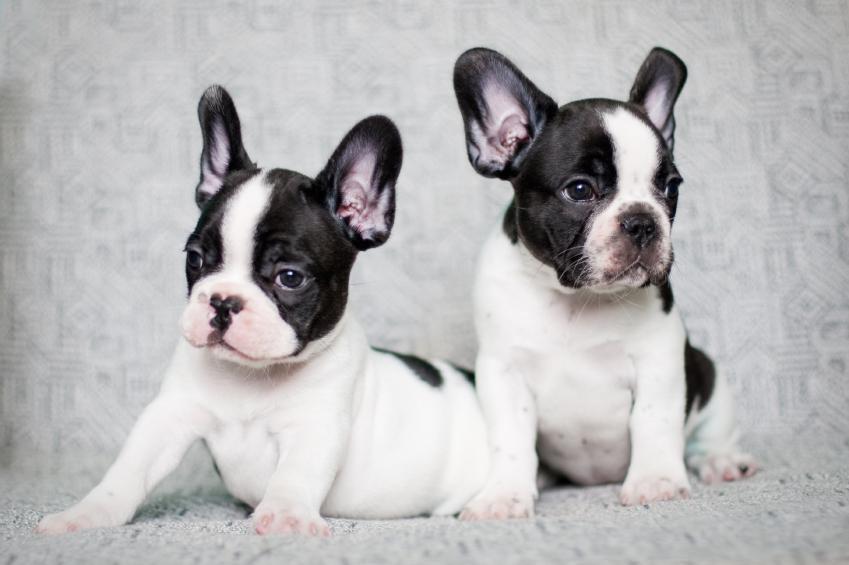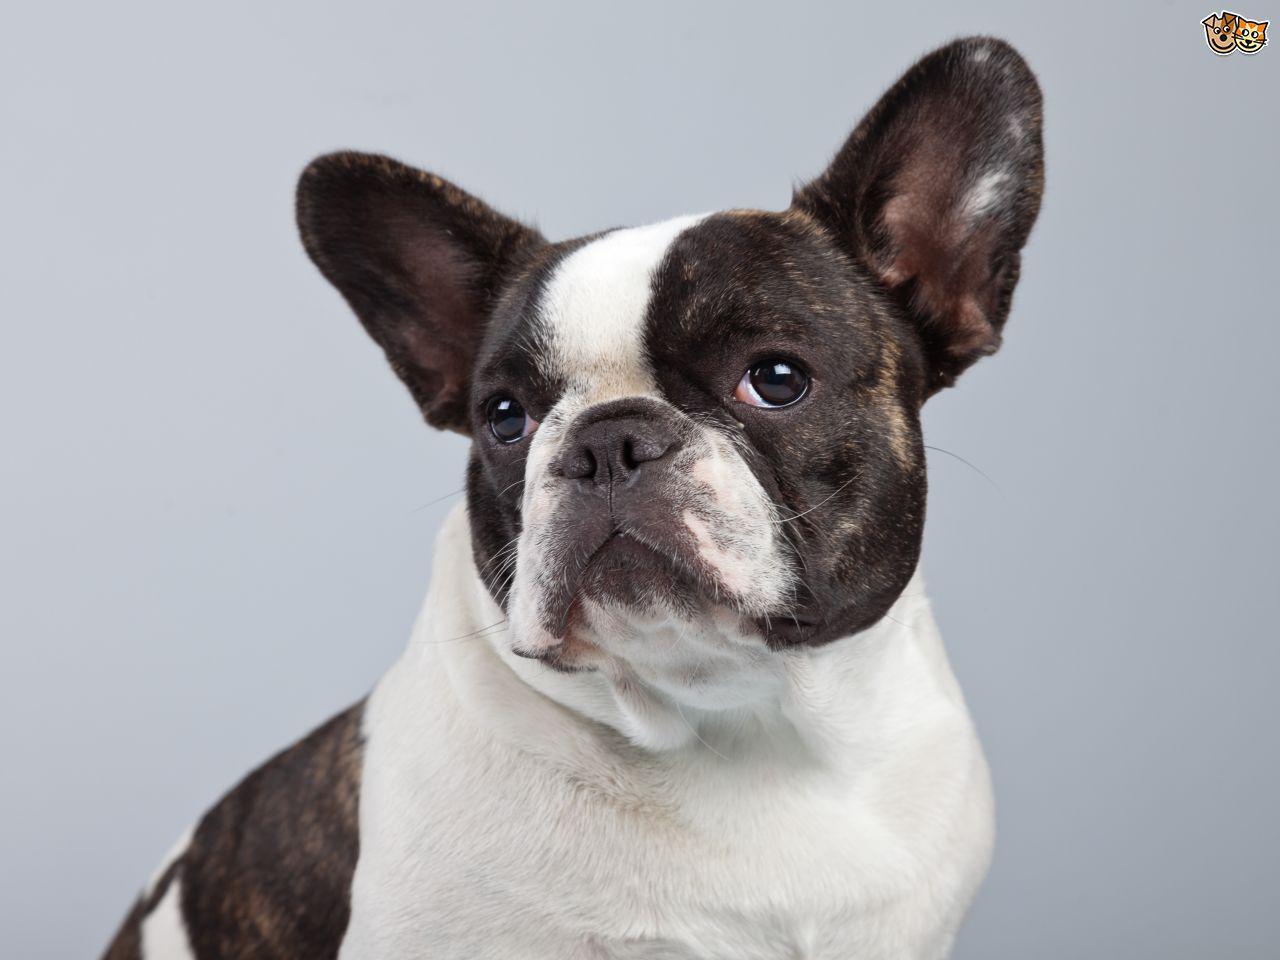The first image is the image on the left, the second image is the image on the right. For the images displayed, is the sentence "The left image includes exactly twice as many dogs as the right image." factually correct? Answer yes or no. Yes. The first image is the image on the left, the second image is the image on the right. Analyze the images presented: Is the assertion "Two dogs are posing together in the image on the left." valid? Answer yes or no. Yes. 